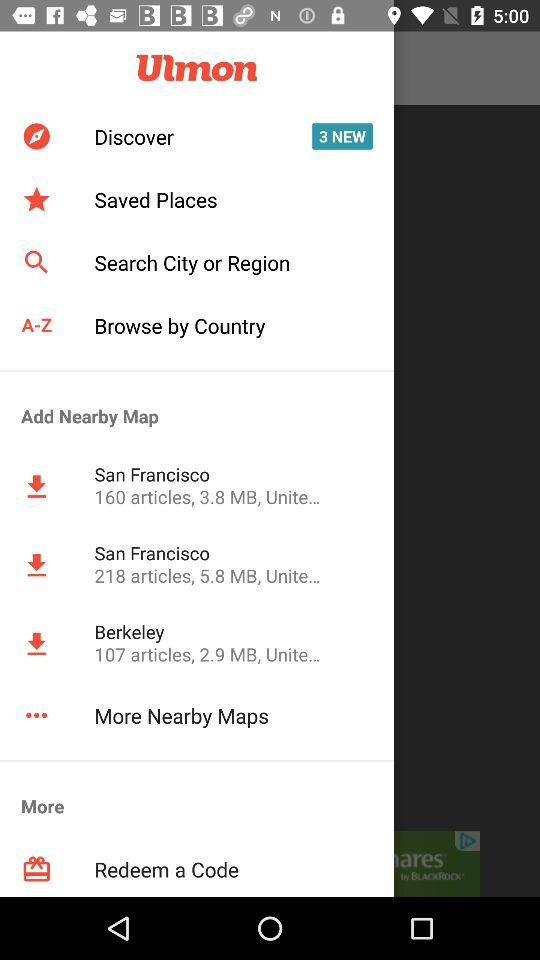How many items are in the 'Discover' section?
Answer the question using a single word or phrase. 3 